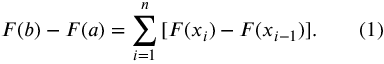Convert formula to latex. <formula><loc_0><loc_0><loc_500><loc_500>F ( b ) - F ( a ) = \sum _ { i = 1 } ^ { n } \, [ F ( x _ { i } ) - F ( x _ { i - 1 } ) ] . \quad ( 1 )</formula> 